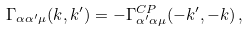<formula> <loc_0><loc_0><loc_500><loc_500>\Gamma _ { \alpha \alpha ^ { \prime } \mu } ( k , k ^ { \prime } ) = - \Gamma ^ { C P } _ { \alpha ^ { \prime } \alpha \mu } ( - k ^ { \prime } , - k ) \, ,</formula> 